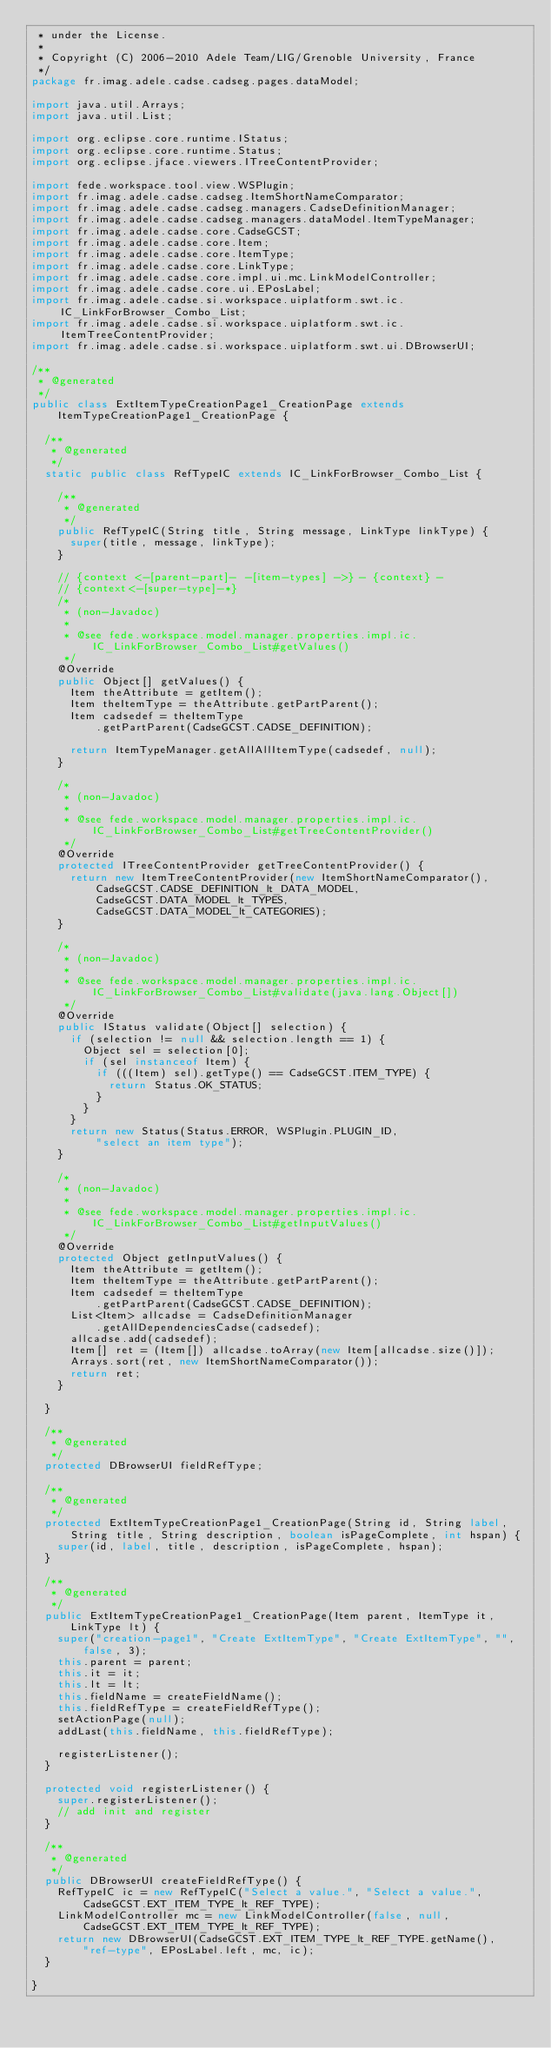<code> <loc_0><loc_0><loc_500><loc_500><_Java_> * under the License.
 *
 * Copyright (C) 2006-2010 Adele Team/LIG/Grenoble University, France
 */
package fr.imag.adele.cadse.cadseg.pages.dataModel;

import java.util.Arrays;
import java.util.List;

import org.eclipse.core.runtime.IStatus;
import org.eclipse.core.runtime.Status;
import org.eclipse.jface.viewers.ITreeContentProvider;

import fede.workspace.tool.view.WSPlugin;
import fr.imag.adele.cadse.cadseg.ItemShortNameComparator;
import fr.imag.adele.cadse.cadseg.managers.CadseDefinitionManager;
import fr.imag.adele.cadse.cadseg.managers.dataModel.ItemTypeManager;
import fr.imag.adele.cadse.core.CadseGCST;
import fr.imag.adele.cadse.core.Item;
import fr.imag.adele.cadse.core.ItemType;
import fr.imag.adele.cadse.core.LinkType;
import fr.imag.adele.cadse.core.impl.ui.mc.LinkModelController;
import fr.imag.adele.cadse.core.ui.EPosLabel;
import fr.imag.adele.cadse.si.workspace.uiplatform.swt.ic.IC_LinkForBrowser_Combo_List;
import fr.imag.adele.cadse.si.workspace.uiplatform.swt.ic.ItemTreeContentProvider;
import fr.imag.adele.cadse.si.workspace.uiplatform.swt.ui.DBrowserUI;

/**
 * @generated
 */
public class ExtItemTypeCreationPage1_CreationPage extends
		ItemTypeCreationPage1_CreationPage {

	/**
	 * @generated
	 */
	static public class RefTypeIC extends IC_LinkForBrowser_Combo_List {

		/**
		 * @generated
		 */
		public RefTypeIC(String title, String message, LinkType linkType) {
			super(title, message, linkType);
		}

		// {context <-[parent-part]- -[item-types] ->} - {context} -
		// {context<-[super-type]-*}
		/*
		 * (non-Javadoc)
		 * 
		 * @see fede.workspace.model.manager.properties.impl.ic.IC_LinkForBrowser_Combo_List#getValues()
		 */
		@Override
		public Object[] getValues() {
			Item theAttribute = getItem();
			Item theItemType = theAttribute.getPartParent();
			Item cadsedef = theItemType
					.getPartParent(CadseGCST.CADSE_DEFINITION);

			return ItemTypeManager.getAllAllItemType(cadsedef, null);
		}

		/*
		 * (non-Javadoc)
		 * 
		 * @see fede.workspace.model.manager.properties.impl.ic.IC_LinkForBrowser_Combo_List#getTreeContentProvider()
		 */
		@Override
		protected ITreeContentProvider getTreeContentProvider() {
			return new ItemTreeContentProvider(new ItemShortNameComparator(),
					CadseGCST.CADSE_DEFINITION_lt_DATA_MODEL,
					CadseGCST.DATA_MODEL_lt_TYPES,
					CadseGCST.DATA_MODEL_lt_CATEGORIES);
		}

		/*
		 * (non-Javadoc)
		 * 
		 * @see fede.workspace.model.manager.properties.impl.ic.IC_LinkForBrowser_Combo_List#validate(java.lang.Object[])
		 */
		@Override
		public IStatus validate(Object[] selection) {
			if (selection != null && selection.length == 1) {
				Object sel = selection[0];
				if (sel instanceof Item) {
					if (((Item) sel).getType() == CadseGCST.ITEM_TYPE) {
						return Status.OK_STATUS;
					}
				}
			}
			return new Status(Status.ERROR, WSPlugin.PLUGIN_ID,
					"select an item type");
		}

		/*
		 * (non-Javadoc)
		 * 
		 * @see fede.workspace.model.manager.properties.impl.ic.IC_LinkForBrowser_Combo_List#getInputValues()
		 */
		@Override
		protected Object getInputValues() {
			Item theAttribute = getItem();
			Item theItemType = theAttribute.getPartParent();
			Item cadsedef = theItemType
					.getPartParent(CadseGCST.CADSE_DEFINITION);
			List<Item> allcadse = CadseDefinitionManager
					.getAllDependenciesCadse(cadsedef);
			allcadse.add(cadsedef);
			Item[] ret = (Item[]) allcadse.toArray(new Item[allcadse.size()]);
			Arrays.sort(ret, new ItemShortNameComparator());
			return ret;
		}

	}

	/**
	 * @generated
	 */
	protected DBrowserUI fieldRefType;

	/**
	 * @generated
	 */
	protected ExtItemTypeCreationPage1_CreationPage(String id, String label,
			String title, String description, boolean isPageComplete, int hspan) {
		super(id, label, title, description, isPageComplete, hspan);
	}

	/**
	 * @generated
	 */
	public ExtItemTypeCreationPage1_CreationPage(Item parent, ItemType it,
			LinkType lt) {
		super("creation-page1", "Create ExtItemType", "Create ExtItemType", "",
				false, 3);
		this.parent = parent;
		this.it = it;
		this.lt = lt;
		this.fieldName = createFieldName();
		this.fieldRefType = createFieldRefType();
		setActionPage(null);
		addLast(this.fieldName, this.fieldRefType);

		registerListener();
	}

	protected void registerListener() {
		super.registerListener();
		// add init and register
	}

	/**
	 * @generated
	 */
	public DBrowserUI createFieldRefType() {
		RefTypeIC ic = new RefTypeIC("Select a value.", "Select a value.",
				CadseGCST.EXT_ITEM_TYPE_lt_REF_TYPE);
		LinkModelController mc = new LinkModelController(false, null,
				CadseGCST.EXT_ITEM_TYPE_lt_REF_TYPE);
		return new DBrowserUI(CadseGCST.EXT_ITEM_TYPE_lt_REF_TYPE.getName(),
				"ref-type", EPosLabel.left, mc, ic);
	}

}
</code> 